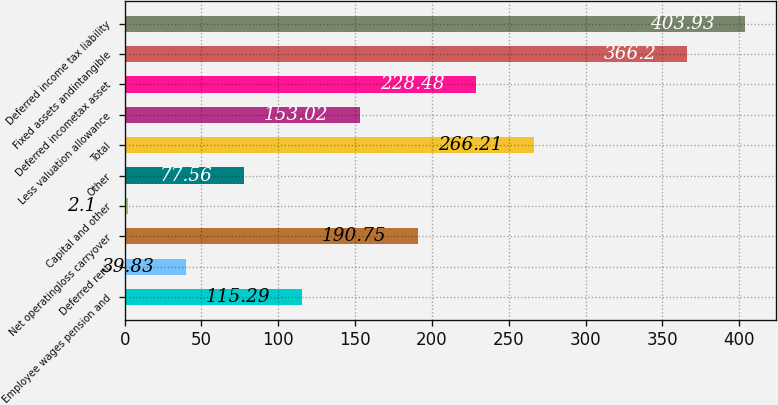Convert chart to OTSL. <chart><loc_0><loc_0><loc_500><loc_500><bar_chart><fcel>Employee wages pension and<fcel>Deferred rent<fcel>Net operatingloss carryover<fcel>Capital and other<fcel>Other<fcel>Total<fcel>Less valuation allowance<fcel>Deferred incometax asset<fcel>Fixed assets andintangible<fcel>Deferred income tax liability<nl><fcel>115.29<fcel>39.83<fcel>190.75<fcel>2.1<fcel>77.56<fcel>266.21<fcel>153.02<fcel>228.48<fcel>366.2<fcel>403.93<nl></chart> 